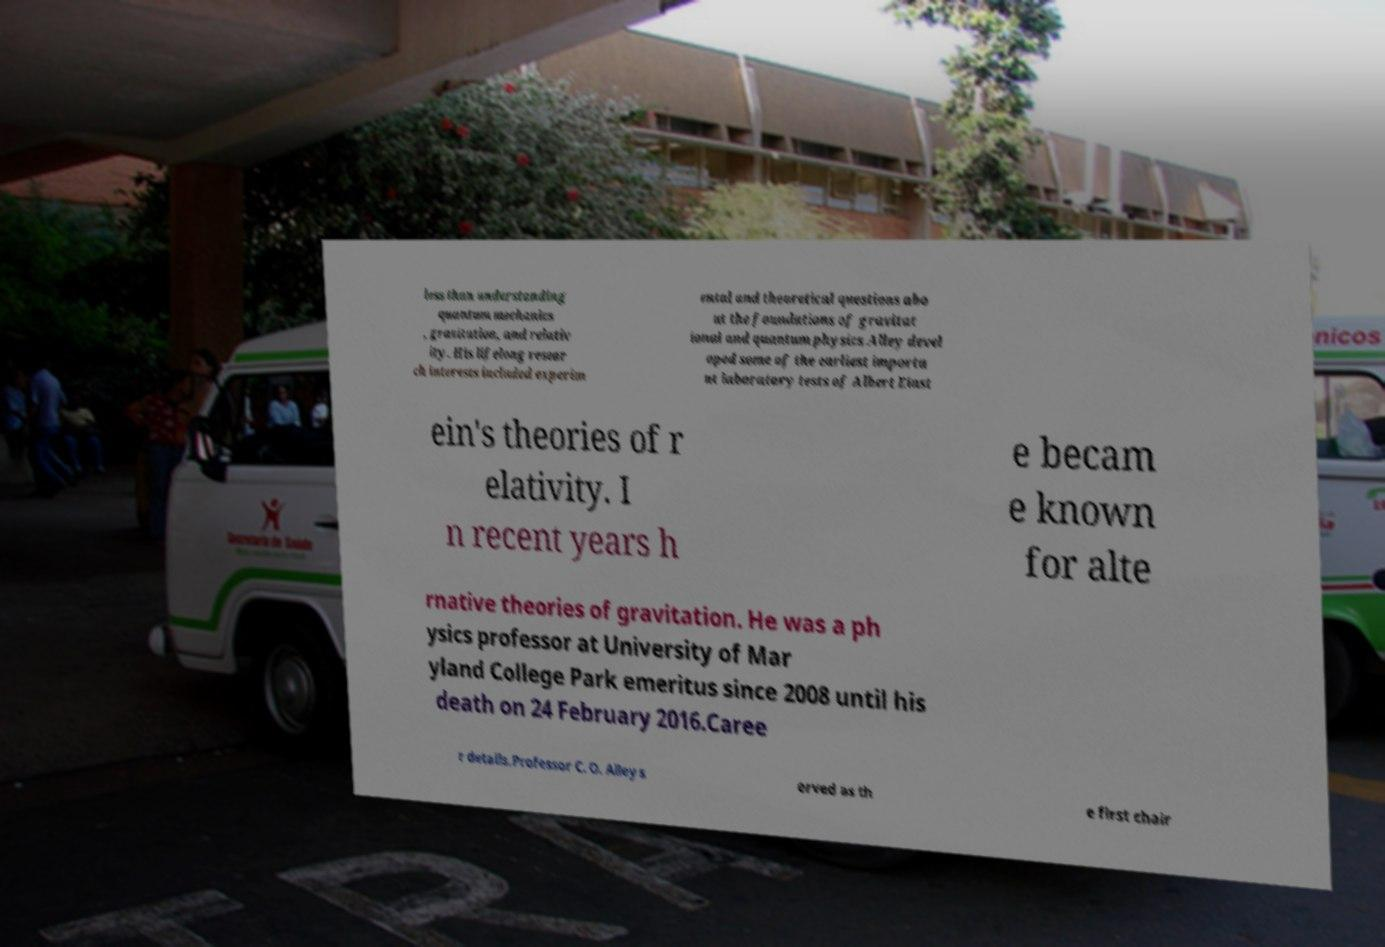I need the written content from this picture converted into text. Can you do that? less than understanding quantum mechanics , gravitation, and relativ ity. His lifelong resear ch interests included experim ental and theoretical questions abo ut the foundations of gravitat ional and quantum physics.Alley devel oped some of the earliest importa nt laboratory tests of Albert Einst ein's theories of r elativity. I n recent years h e becam e known for alte rnative theories of gravitation. He was a ph ysics professor at University of Mar yland College Park emeritus since 2008 until his death on 24 February 2016.Caree r details.Professor C. O. Alley s erved as th e first chair 